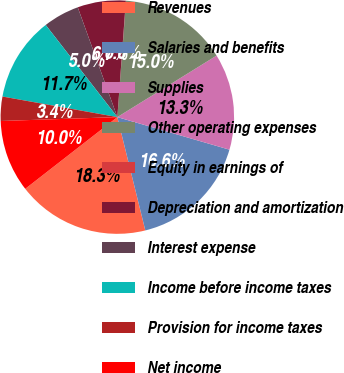<chart> <loc_0><loc_0><loc_500><loc_500><pie_chart><fcel>Revenues<fcel>Salaries and benefits<fcel>Supplies<fcel>Other operating expenses<fcel>Equity in earnings of<fcel>Depreciation and amortization<fcel>Interest expense<fcel>Income before income taxes<fcel>Provision for income taxes<fcel>Net income<nl><fcel>18.32%<fcel>16.65%<fcel>13.33%<fcel>14.99%<fcel>0.02%<fcel>6.67%<fcel>5.01%<fcel>11.66%<fcel>3.35%<fcel>10.0%<nl></chart> 